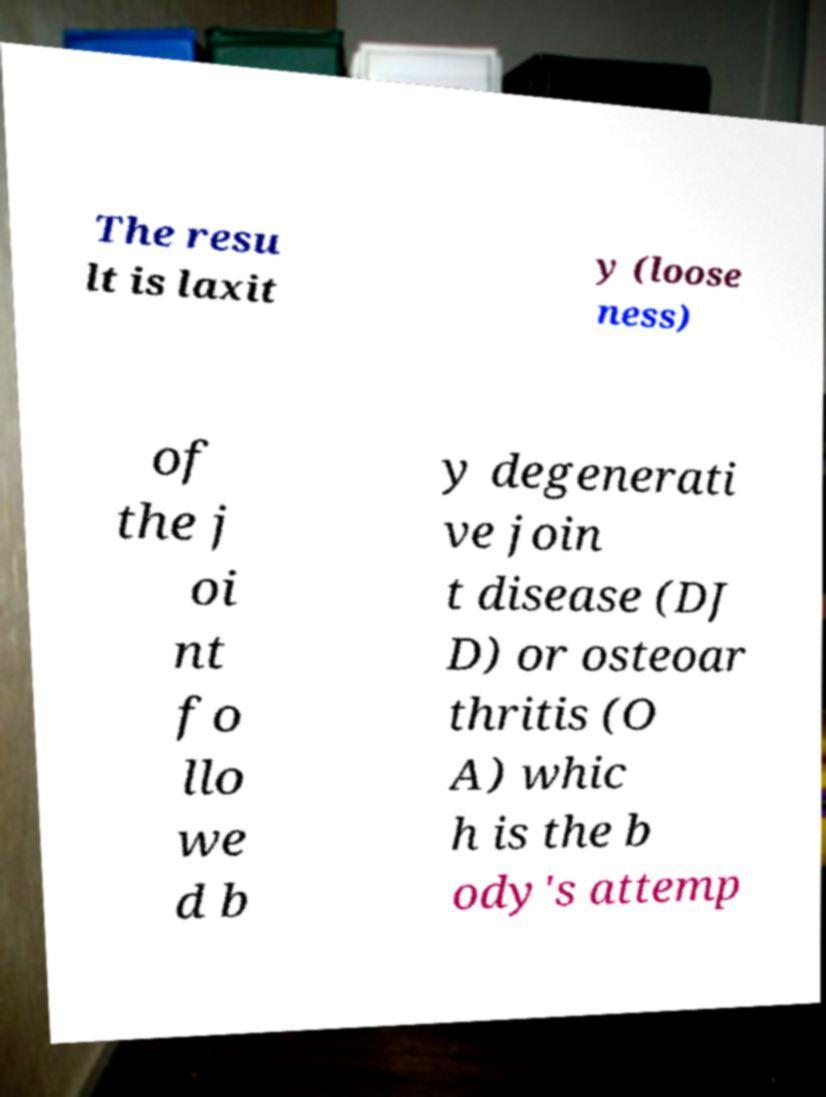Please identify and transcribe the text found in this image. The resu lt is laxit y (loose ness) of the j oi nt fo llo we d b y degenerati ve join t disease (DJ D) or osteoar thritis (O A) whic h is the b ody's attemp 